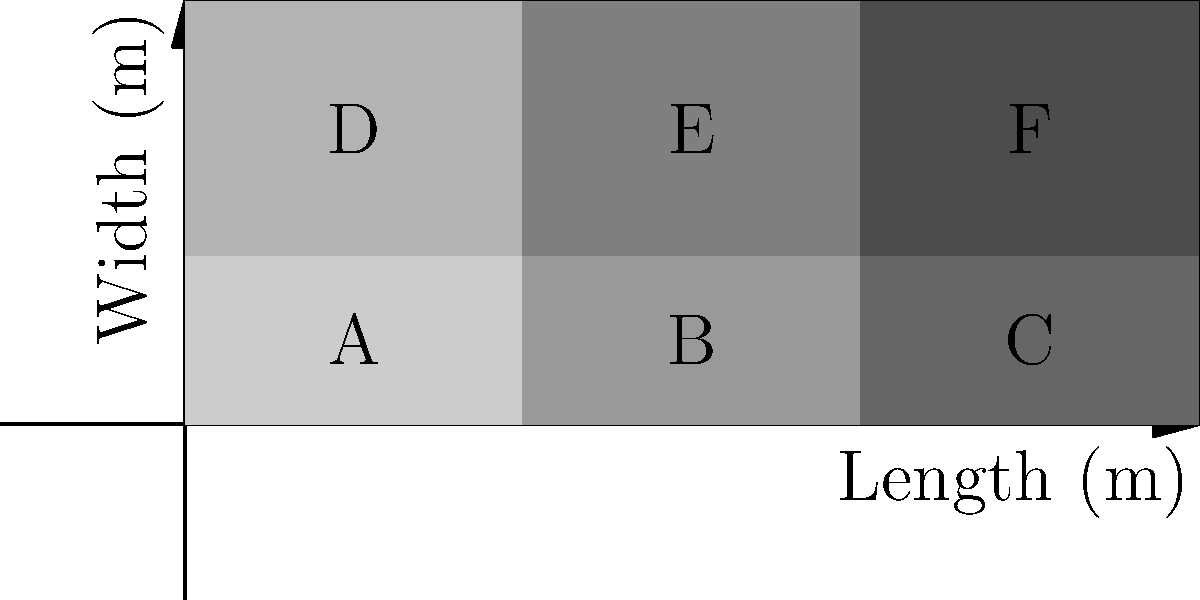A food processing company is optimizing its truck loading patterns. The diagram shows a top-down view of a truck loaded with six different types of products (A-F). Each product type can be represented as a vector in 3D space, where the dimensions represent weight (kg), volume (m³), and fragility (on a scale of 1-10). Given the following product vectors:

A: $\vec{a} = (100, 2, 3)$
B: $\vec{b} = (150, 3, 5)$
C: $\vec{c} = (200, 4, 7)$
D: $\vec{d} = (120, 2.5, 4)$
E: $\vec{e} = (180, 3.5, 6)$
F: $\vec{f} = (250, 5, 8)$

Calculate the total vector representation of the loaded truck. To calculate the total vector representation of the loaded truck, we need to sum up all the individual product vectors. This process involves adding the corresponding components of each vector.

Step 1: Set up the sum of vectors
$$\vec{total} = \vec{a} + \vec{b} + \vec{c} + \vec{d} + \vec{e} + \vec{f}$$

Step 2: Add the weight components (first element of each vector)
Weight = 100 + 150 + 200 + 120 + 180 + 250 = 1000 kg

Step 3: Add the volume components (second element of each vector)
Volume = 2 + 3 + 4 + 2.5 + 3.5 + 5 = 20 m³

Step 4: Add the fragility components (third element of each vector)
Fragility = 3 + 5 + 7 + 4 + 6 + 8 = 33

Step 5: Combine the results into a single vector
$$\vec{total} = (1000, 20, 33)$$

This vector represents the total weight (1000 kg), volume (20 m³), and cumulative fragility score (33) of all products loaded in the truck.
Answer: $(1000, 20, 33)$ 